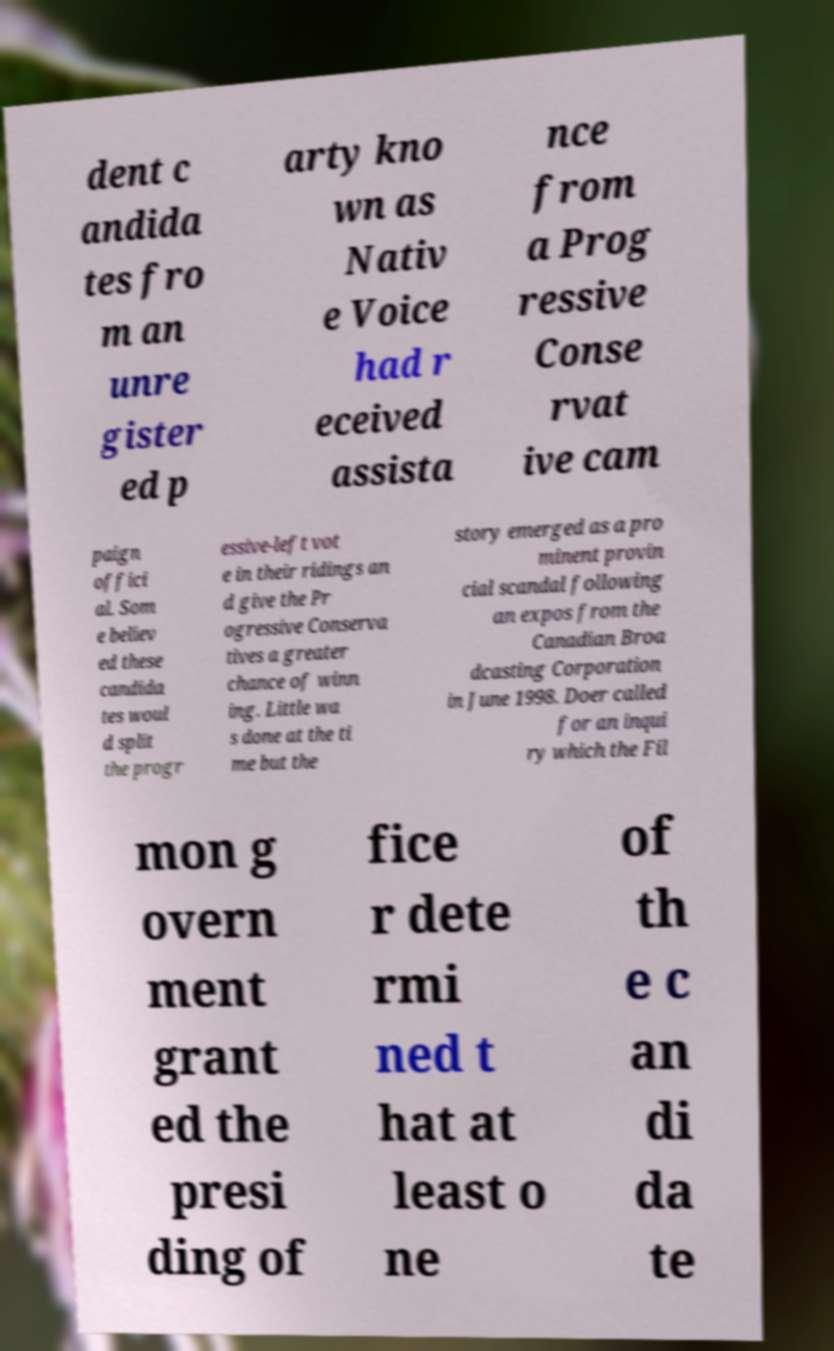I need the written content from this picture converted into text. Can you do that? dent c andida tes fro m an unre gister ed p arty kno wn as Nativ e Voice had r eceived assista nce from a Prog ressive Conse rvat ive cam paign offici al. Som e believ ed these candida tes woul d split the progr essive-left vot e in their ridings an d give the Pr ogressive Conserva tives a greater chance of winn ing. Little wa s done at the ti me but the story emerged as a pro minent provin cial scandal following an expos from the Canadian Broa dcasting Corporation in June 1998. Doer called for an inqui ry which the Fil mon g overn ment grant ed the presi ding of fice r dete rmi ned t hat at least o ne of th e c an di da te 